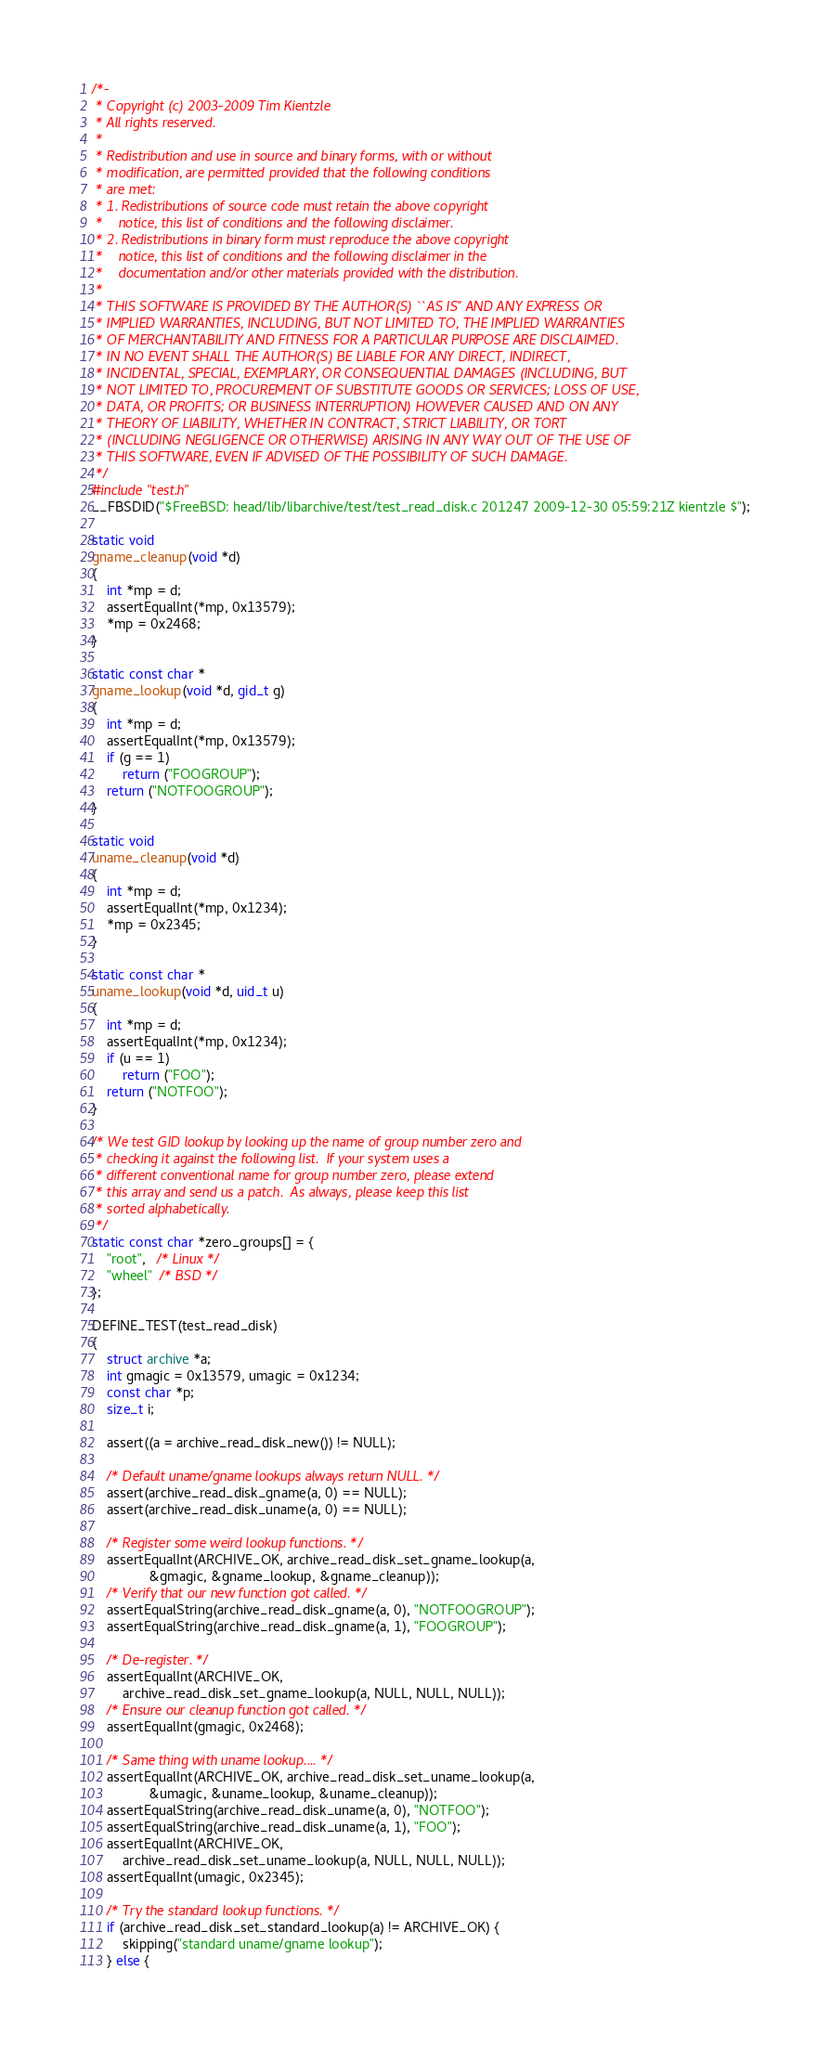Convert code to text. <code><loc_0><loc_0><loc_500><loc_500><_C_>/*-
 * Copyright (c) 2003-2009 Tim Kientzle
 * All rights reserved.
 *
 * Redistribution and use in source and binary forms, with or without
 * modification, are permitted provided that the following conditions
 * are met:
 * 1. Redistributions of source code must retain the above copyright
 *    notice, this list of conditions and the following disclaimer.
 * 2. Redistributions in binary form must reproduce the above copyright
 *    notice, this list of conditions and the following disclaimer in the
 *    documentation and/or other materials provided with the distribution.
 *
 * THIS SOFTWARE IS PROVIDED BY THE AUTHOR(S) ``AS IS'' AND ANY EXPRESS OR
 * IMPLIED WARRANTIES, INCLUDING, BUT NOT LIMITED TO, THE IMPLIED WARRANTIES
 * OF MERCHANTABILITY AND FITNESS FOR A PARTICULAR PURPOSE ARE DISCLAIMED.
 * IN NO EVENT SHALL THE AUTHOR(S) BE LIABLE FOR ANY DIRECT, INDIRECT,
 * INCIDENTAL, SPECIAL, EXEMPLARY, OR CONSEQUENTIAL DAMAGES (INCLUDING, BUT
 * NOT LIMITED TO, PROCUREMENT OF SUBSTITUTE GOODS OR SERVICES; LOSS OF USE,
 * DATA, OR PROFITS; OR BUSINESS INTERRUPTION) HOWEVER CAUSED AND ON ANY
 * THEORY OF LIABILITY, WHETHER IN CONTRACT, STRICT LIABILITY, OR TORT
 * (INCLUDING NEGLIGENCE OR OTHERWISE) ARISING IN ANY WAY OUT OF THE USE OF
 * THIS SOFTWARE, EVEN IF ADVISED OF THE POSSIBILITY OF SUCH DAMAGE.
 */
#include "test.h"
__FBSDID("$FreeBSD: head/lib/libarchive/test/test_read_disk.c 201247 2009-12-30 05:59:21Z kientzle $");

static void
gname_cleanup(void *d)
{
	int *mp = d;
	assertEqualInt(*mp, 0x13579);
	*mp = 0x2468;
}

static const char *
gname_lookup(void *d, gid_t g)
{
	int *mp = d;
	assertEqualInt(*mp, 0x13579);
	if (g == 1)
		return ("FOOGROUP");
	return ("NOTFOOGROUP");
}

static void
uname_cleanup(void *d)
{
	int *mp = d;
	assertEqualInt(*mp, 0x1234);
	*mp = 0x2345;
}

static const char *
uname_lookup(void *d, uid_t u)
{
	int *mp = d;
	assertEqualInt(*mp, 0x1234);
	if (u == 1)
		return ("FOO");
	return ("NOTFOO");
}

/* We test GID lookup by looking up the name of group number zero and
 * checking it against the following list.  If your system uses a
 * different conventional name for group number zero, please extend
 * this array and send us a patch.  As always, please keep this list
 * sorted alphabetically.
 */
static const char *zero_groups[] = {
	"root",   /* Linux */
	"wheel"  /* BSD */
};

DEFINE_TEST(test_read_disk)
{
	struct archive *a;
	int gmagic = 0x13579, umagic = 0x1234;
	const char *p;
	size_t i;

	assert((a = archive_read_disk_new()) != NULL);

	/* Default uname/gname lookups always return NULL. */
	assert(archive_read_disk_gname(a, 0) == NULL);
	assert(archive_read_disk_uname(a, 0) == NULL);

	/* Register some weird lookup functions. */
	assertEqualInt(ARCHIVE_OK, archive_read_disk_set_gname_lookup(a,
			   &gmagic, &gname_lookup, &gname_cleanup));
	/* Verify that our new function got called. */
	assertEqualString(archive_read_disk_gname(a, 0), "NOTFOOGROUP");
	assertEqualString(archive_read_disk_gname(a, 1), "FOOGROUP");

	/* De-register. */
	assertEqualInt(ARCHIVE_OK,
	    archive_read_disk_set_gname_lookup(a, NULL, NULL, NULL));
	/* Ensure our cleanup function got called. */
	assertEqualInt(gmagic, 0x2468);

	/* Same thing with uname lookup.... */
	assertEqualInt(ARCHIVE_OK, archive_read_disk_set_uname_lookup(a,
			   &umagic, &uname_lookup, &uname_cleanup));
	assertEqualString(archive_read_disk_uname(a, 0), "NOTFOO");
	assertEqualString(archive_read_disk_uname(a, 1), "FOO");
	assertEqualInt(ARCHIVE_OK,
	    archive_read_disk_set_uname_lookup(a, NULL, NULL, NULL));
	assertEqualInt(umagic, 0x2345);

	/* Try the standard lookup functions. */
	if (archive_read_disk_set_standard_lookup(a) != ARCHIVE_OK) {
		skipping("standard uname/gname lookup");
	} else {</code> 